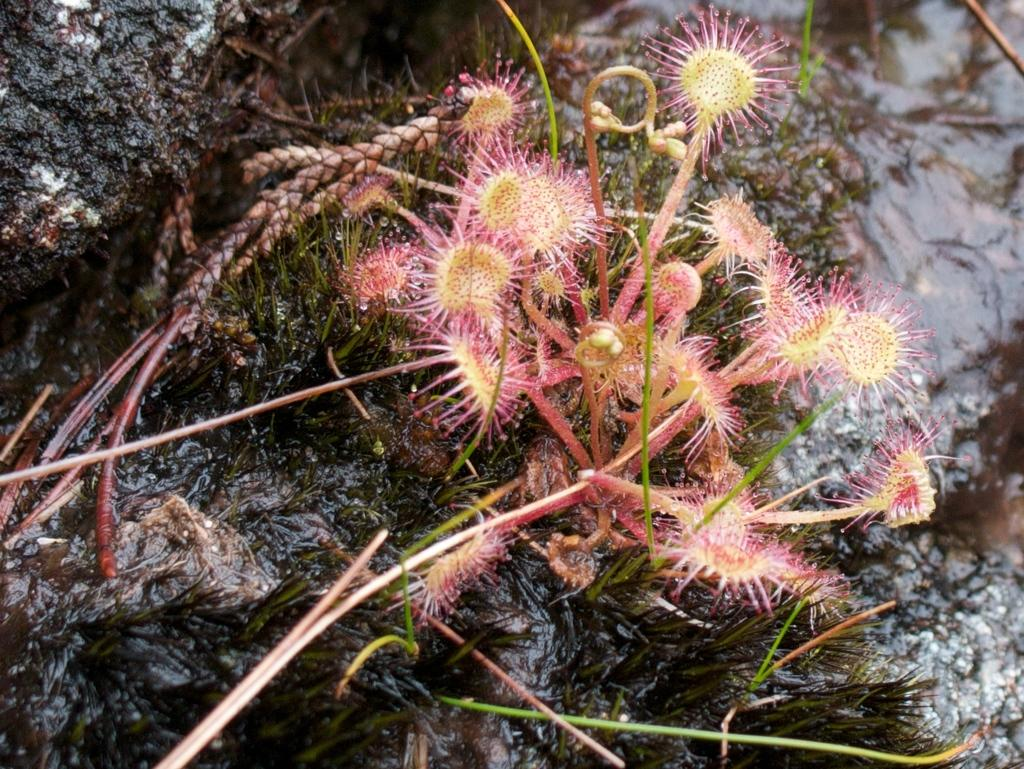What type of plants are in the image? There are aquatic plants in the image. What is visible in the background of the image? There is water visible in the background of the image. What can be seen on the left side of the image? There are rocks on the left side of the image. Can you hear the sound of thunder in the image? There is no sound present in the image, so it is not possible to hear thunder or any other sounds. 